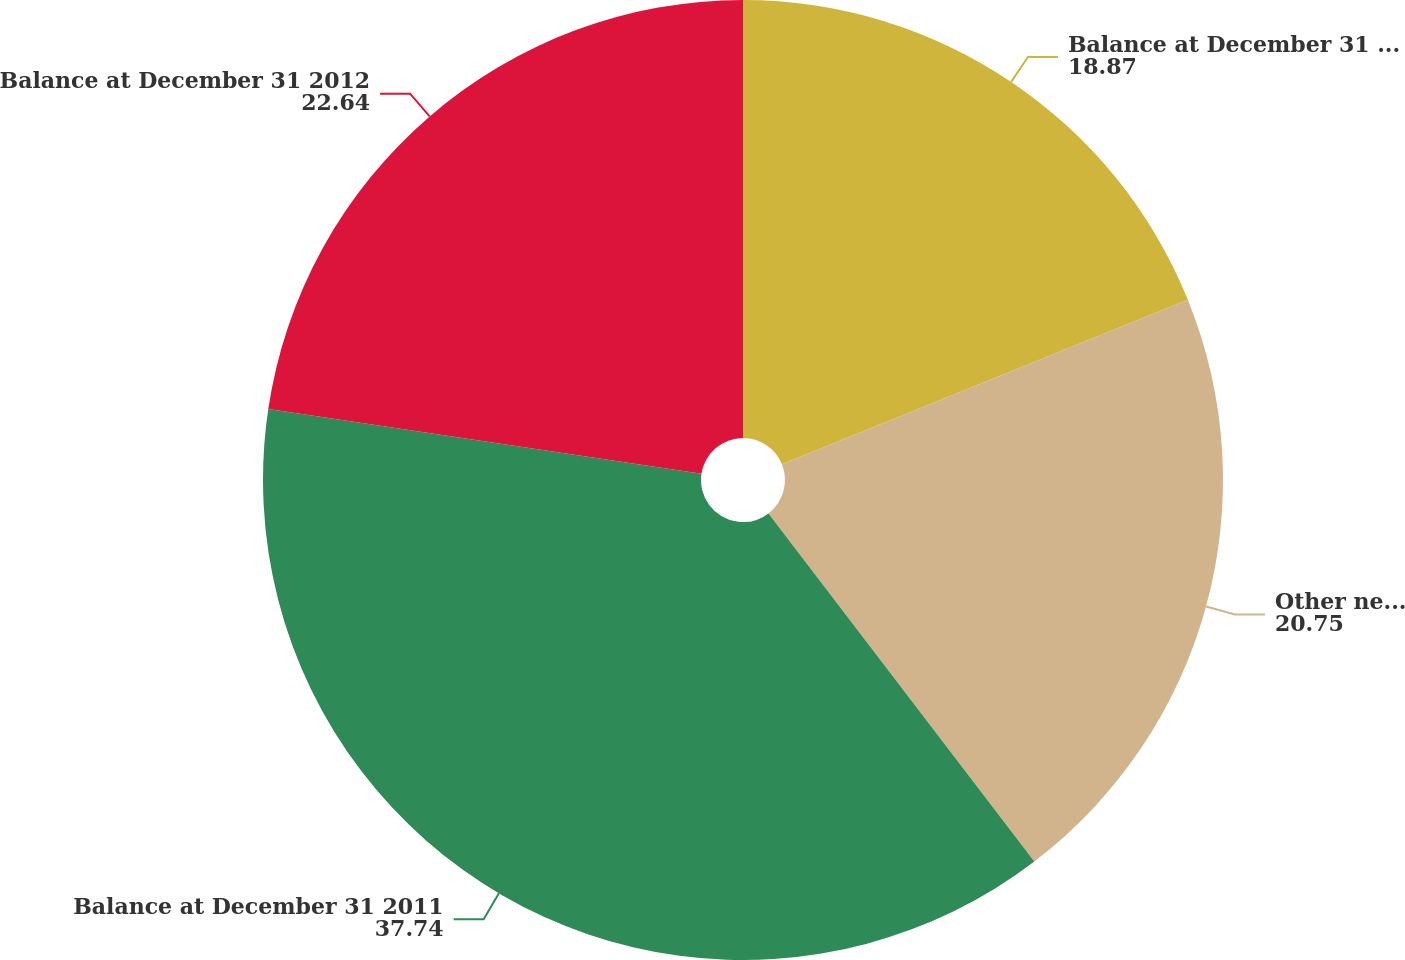Convert chart. <chart><loc_0><loc_0><loc_500><loc_500><pie_chart><fcel>Balance at December 31 2010<fcel>Other net changes<fcel>Balance at December 31 2011<fcel>Balance at December 31 2012<nl><fcel>18.87%<fcel>20.75%<fcel>37.74%<fcel>22.64%<nl></chart> 